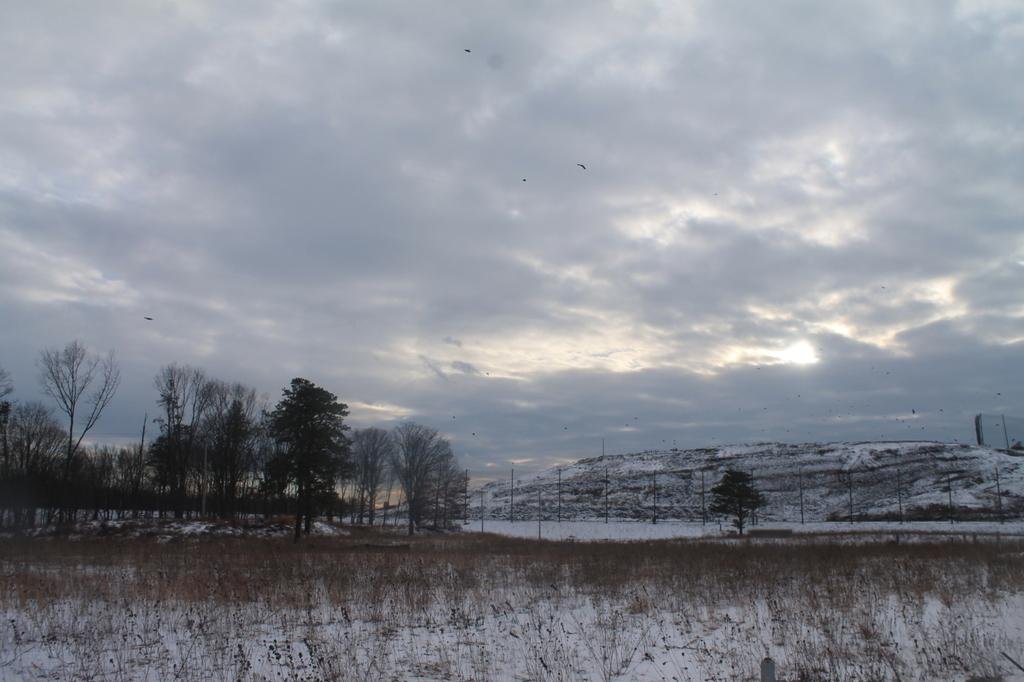What type of vegetation is present in the image? There are trees in the image. What other objects can be seen in the image? There are poles and grass visible in the image. What is the weather like in the image? The image depicts snow, indicating a cold and likely wintery scene. What is visible in the background of the image? There is a mountain and the sky in the background of the image. What can be seen in the sky? Clouds are present in the sky. What type of soup is being served on the tongue in the image? There is no tongue or soup present in the image; it features trees, poles, grass, snow, a mountain, and the sky. Can you tell me how many daughters are visible in the image? There are no daughters present in the image. 